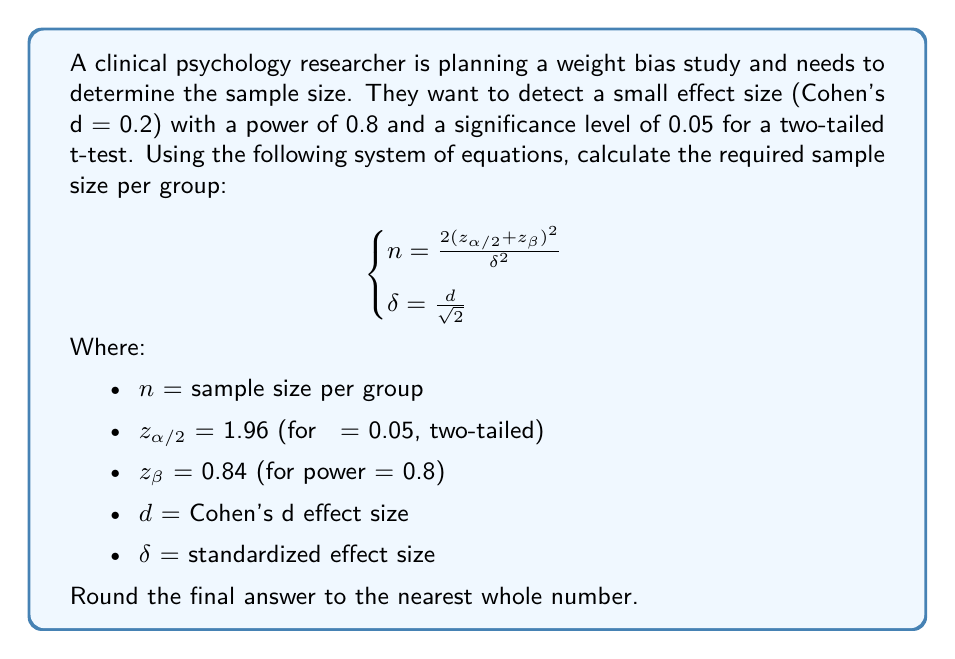Give your solution to this math problem. To solve this problem, we'll follow these steps:

1. Calculate $\delta$ using the given Cohen's d:
   $$\delta = \frac{d}{\sqrt{2}} = \frac{0.2}{\sqrt{2}} = \frac{0.2}{1.414} \approx 0.1414$$

2. Substitute the known values into the sample size equation:
   $$n = \frac{2(z_{\alpha/2} + z_{\beta})^2}{\delta^2}$$
   $$n = \frac{2(1.96 + 0.84)^2}{0.1414^2}$$

3. Simplify the numerator:
   $$n = \frac{2(2.80)^2}{0.1414^2} = \frac{2(7.84)}{0.1414^2} = \frac{15.68}{0.1414^2}$$

4. Calculate the final result:
   $$n = \frac{15.68}{0.02} = 784$$

5. Round to the nearest whole number:
   $$n \approx 784$$

Therefore, the researcher needs 784 participants per group for their weight bias study.
Answer: 784 participants per group 